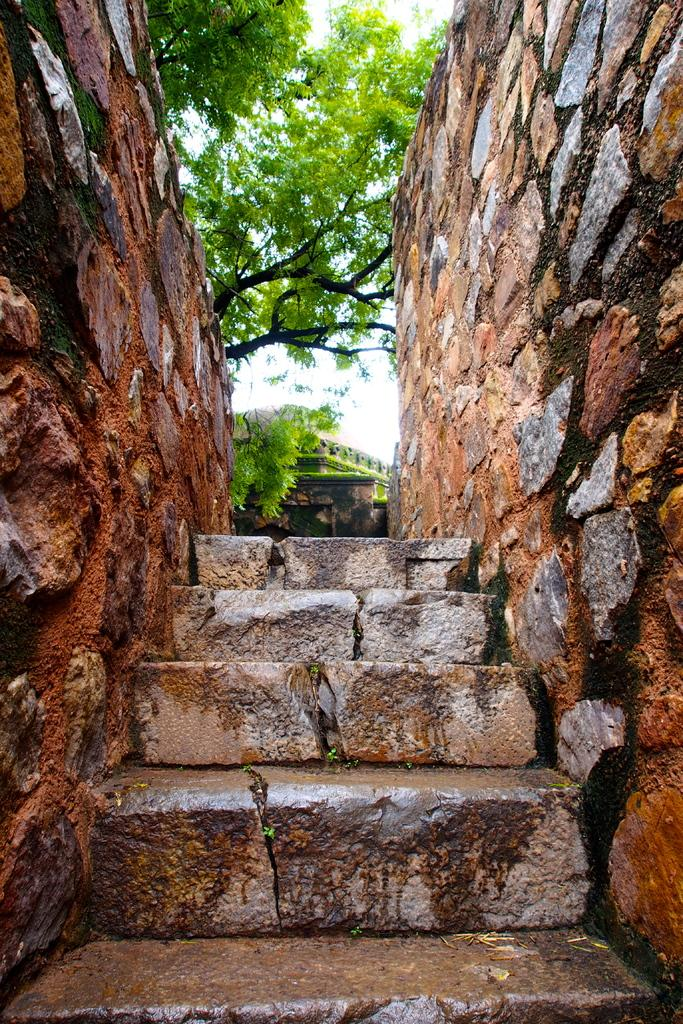What is located in the center of the image? There are stairs in the center of the image. What can be seen on the right side of the image? There is a wall on the right side of the image. What is on the left side of the image? There is a wall on the left side of the image. What is visible in the background of the image? There are trees and a house in the background of the image. How many loaves of bread are hanging on the wall in the image? There is no bread present in the image; it features stairs, walls, trees, and a house in the background. What type of spiders can be seen crawling on the stairs in the image? There are no spiders visible in the image; it only shows stairs, walls, trees, and a house in the background. 